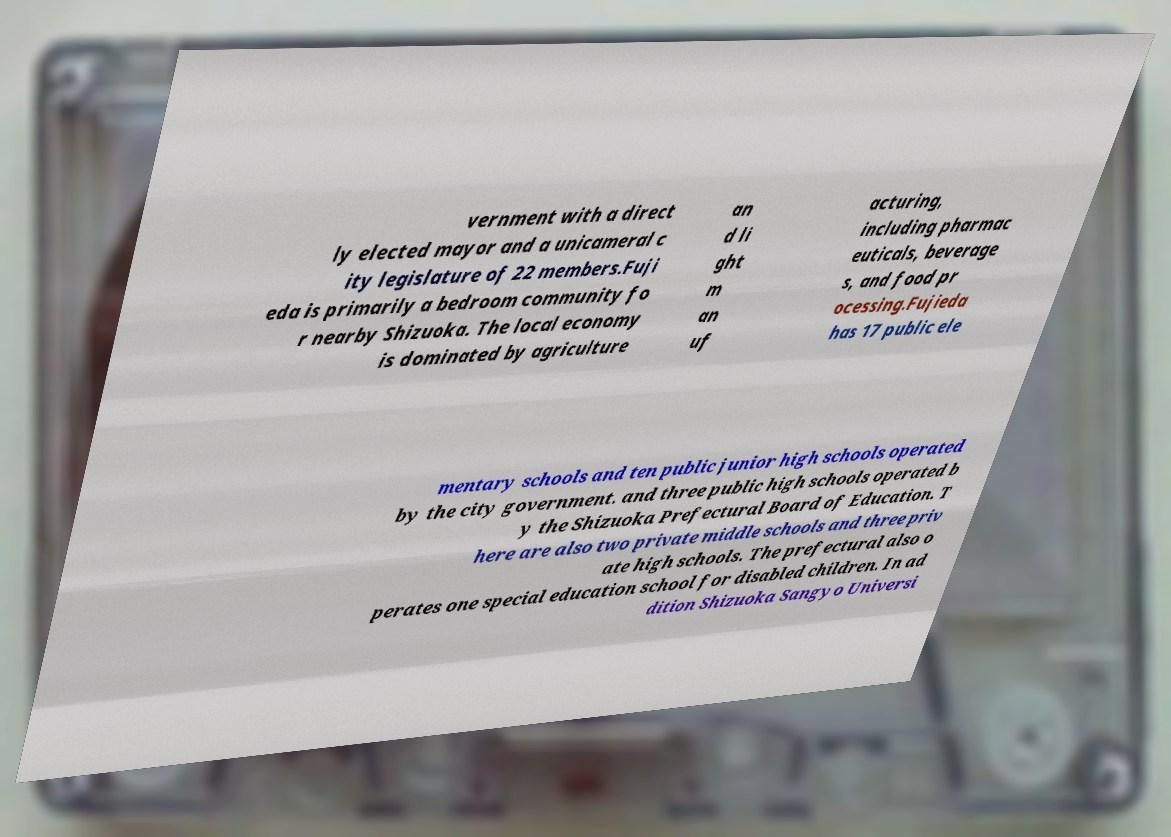Can you accurately transcribe the text from the provided image for me? vernment with a direct ly elected mayor and a unicameral c ity legislature of 22 members.Fuji eda is primarily a bedroom community fo r nearby Shizuoka. The local economy is dominated by agriculture an d li ght m an uf acturing, including pharmac euticals, beverage s, and food pr ocessing.Fujieda has 17 public ele mentary schools and ten public junior high schools operated by the city government. and three public high schools operated b y the Shizuoka Prefectural Board of Education. T here are also two private middle schools and three priv ate high schools. The prefectural also o perates one special education school for disabled children. In ad dition Shizuoka Sangyo Universi 